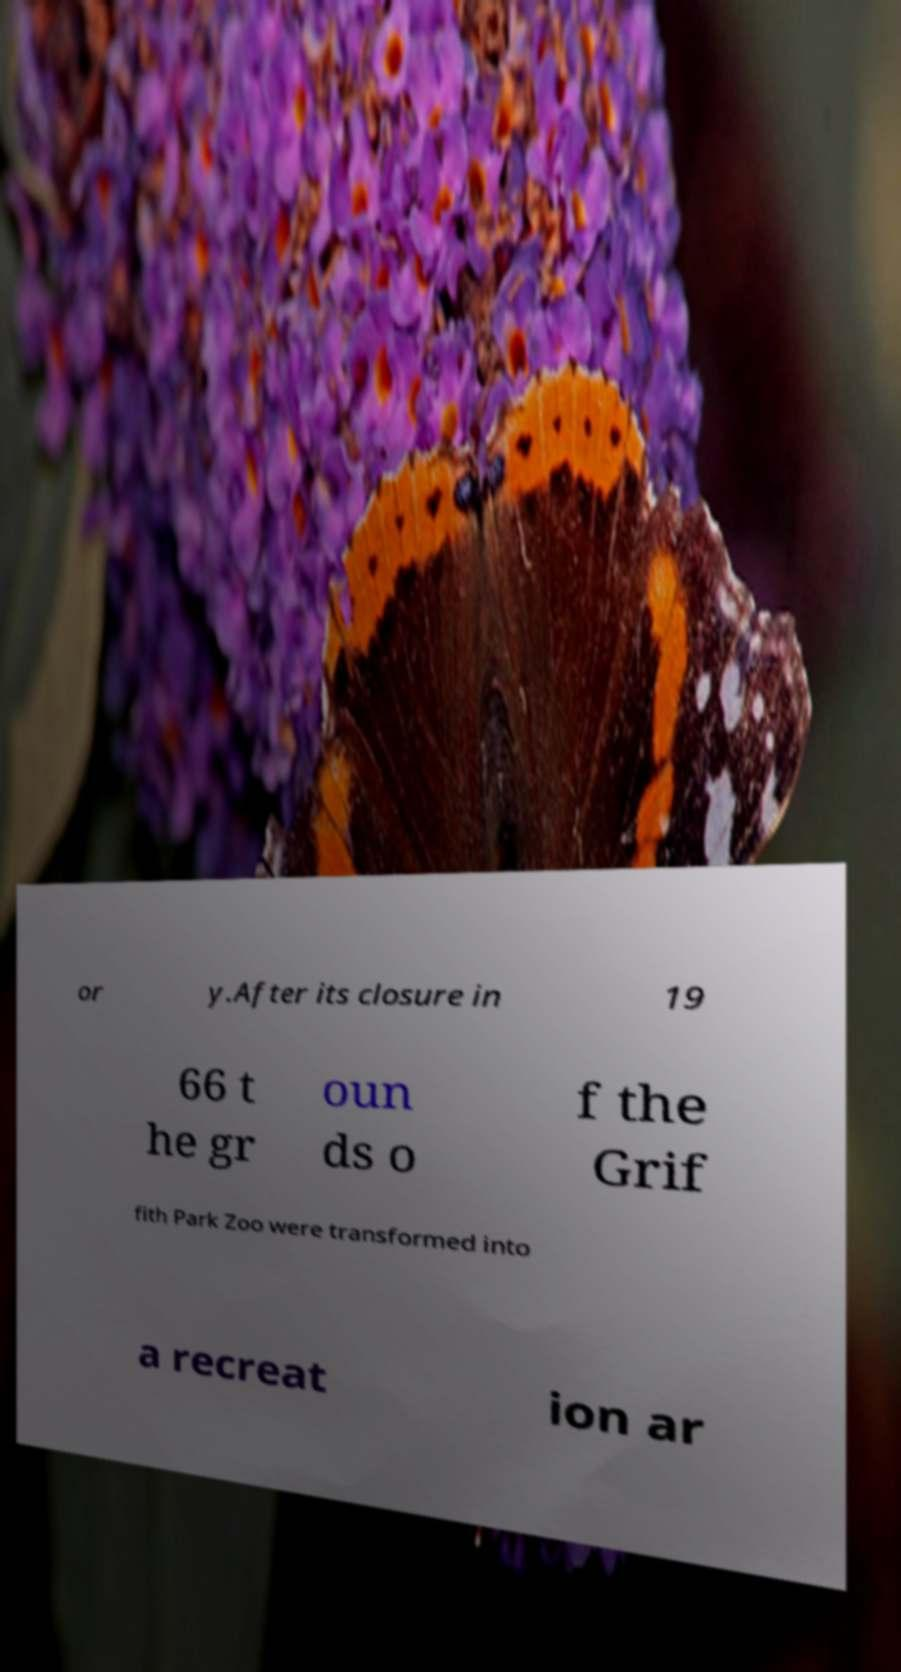Can you read and provide the text displayed in the image?This photo seems to have some interesting text. Can you extract and type it out for me? or y.After its closure in 19 66 t he gr oun ds o f the Grif fith Park Zoo were transformed into a recreat ion ar 